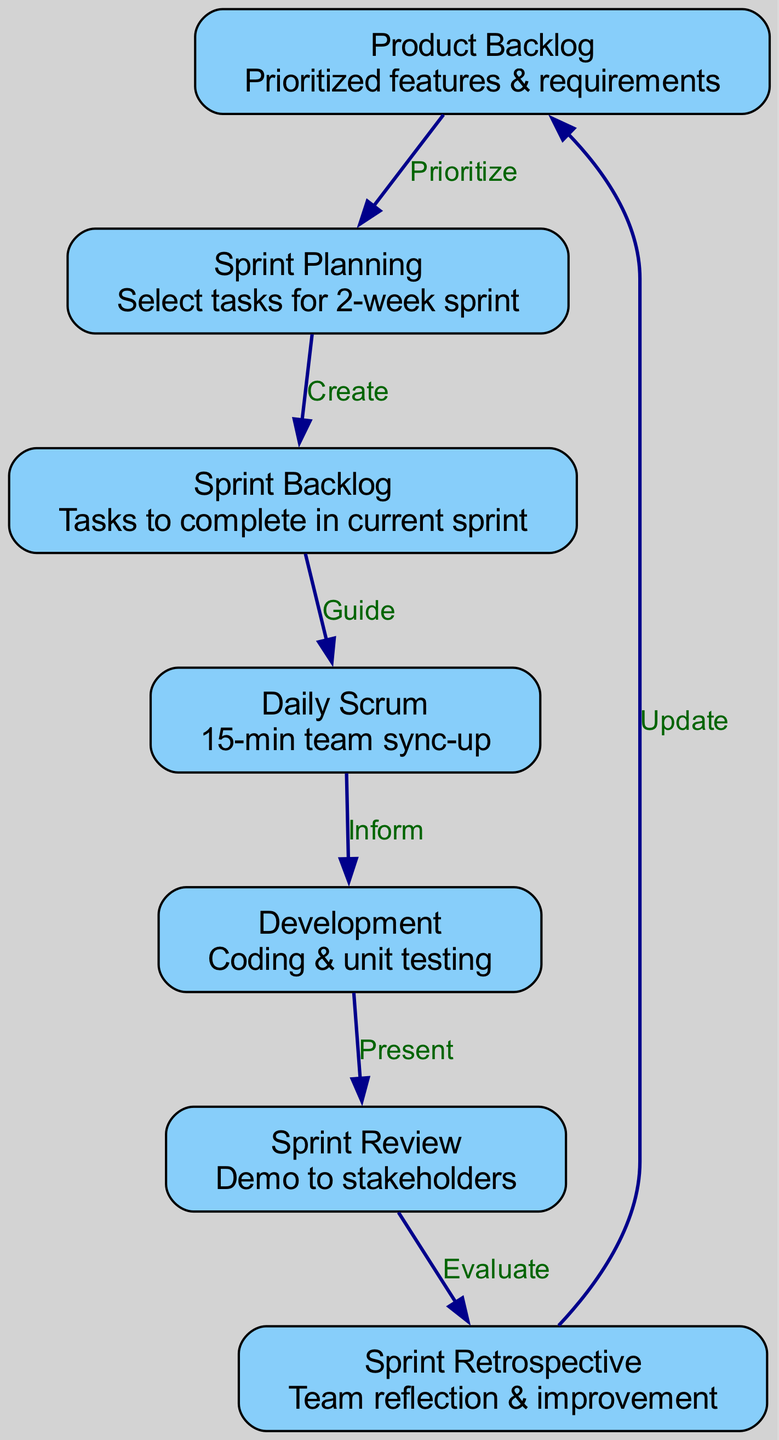What is the starting point of the Agile Software Development Lifecycle? The starting point of the Agile Software Development Lifecycle is represented by the node labeled "Product Backlog," which contains prioritized features and requirements.
Answer: Product Backlog How many nodes are present in the diagram? The diagram lists a total of seven distinct nodes representing different stages in the Agile methodology. These nodes are: Product Backlog, Sprint Planning, Sprint Backlog, Daily Scrum, Development, Sprint Review, and Sprint Retrospective.
Answer: Seven What does the edge between "Sprint Planning" and "Sprint Backlog" represent? The edge between "Sprint Planning" and "Sprint Backlog" is labeled "Create," indicating that during the Sprint Planning phase, tasks are created for the Sprint Backlog.
Answer: Create Which node follows "Daily Scrum" in the sequence? Following "Daily Scrum," the next node in the sequence is "Development," indicating that after daily team synchronization, the coding and unit testing phase begins.
Answer: Development What is the purpose of the "Sprint Retrospective" node? The "Sprint Retrospective" node is focused on "Team reflection & improvement," which highlights its purpose of allowing team members to evaluate the past sprint and suggest improvements for future sprints.
Answer: Team reflection & improvement What type of relationship does "Sprint Review" have with "Sprint Retrospective"? "Sprint Review" has an evaluative relationship with "Sprint Retrospective," as indicated by the "Evaluate" label on the edge connecting these nodes. This signifies that feedback from the Sprint Review informs the improvements discussed in the Retrospective.
Answer: Evaluate Which phase in the process contains a task duration of two weeks? The phase name associated with a two-week duration is "Sprint Planning," as it involves selecting tasks for a 2-week sprint.
Answer: Sprint Planning Which node directly leads back to the "Product Backlog"? The "Sprint Retrospective" node directly leads back to the "Product Backlog," indicating that reflections and improvements discussed during the Retrospective can lead to updates in the backlog.
Answer: Sprint Retrospective 